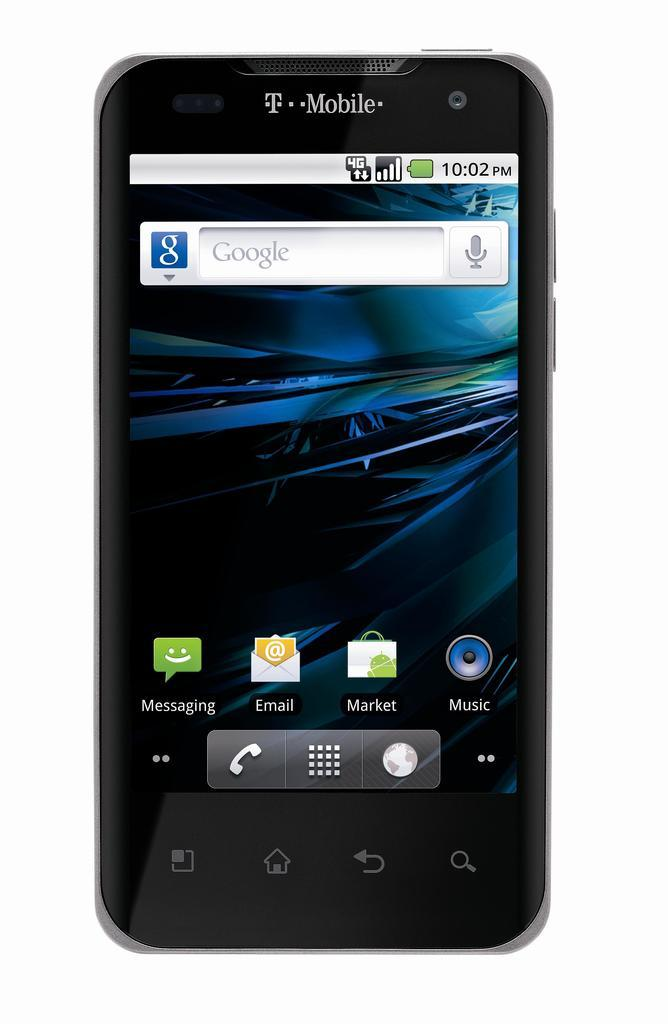<image>
Describe the image concisely. An old T-mobile phone is sitting on the home screen. 